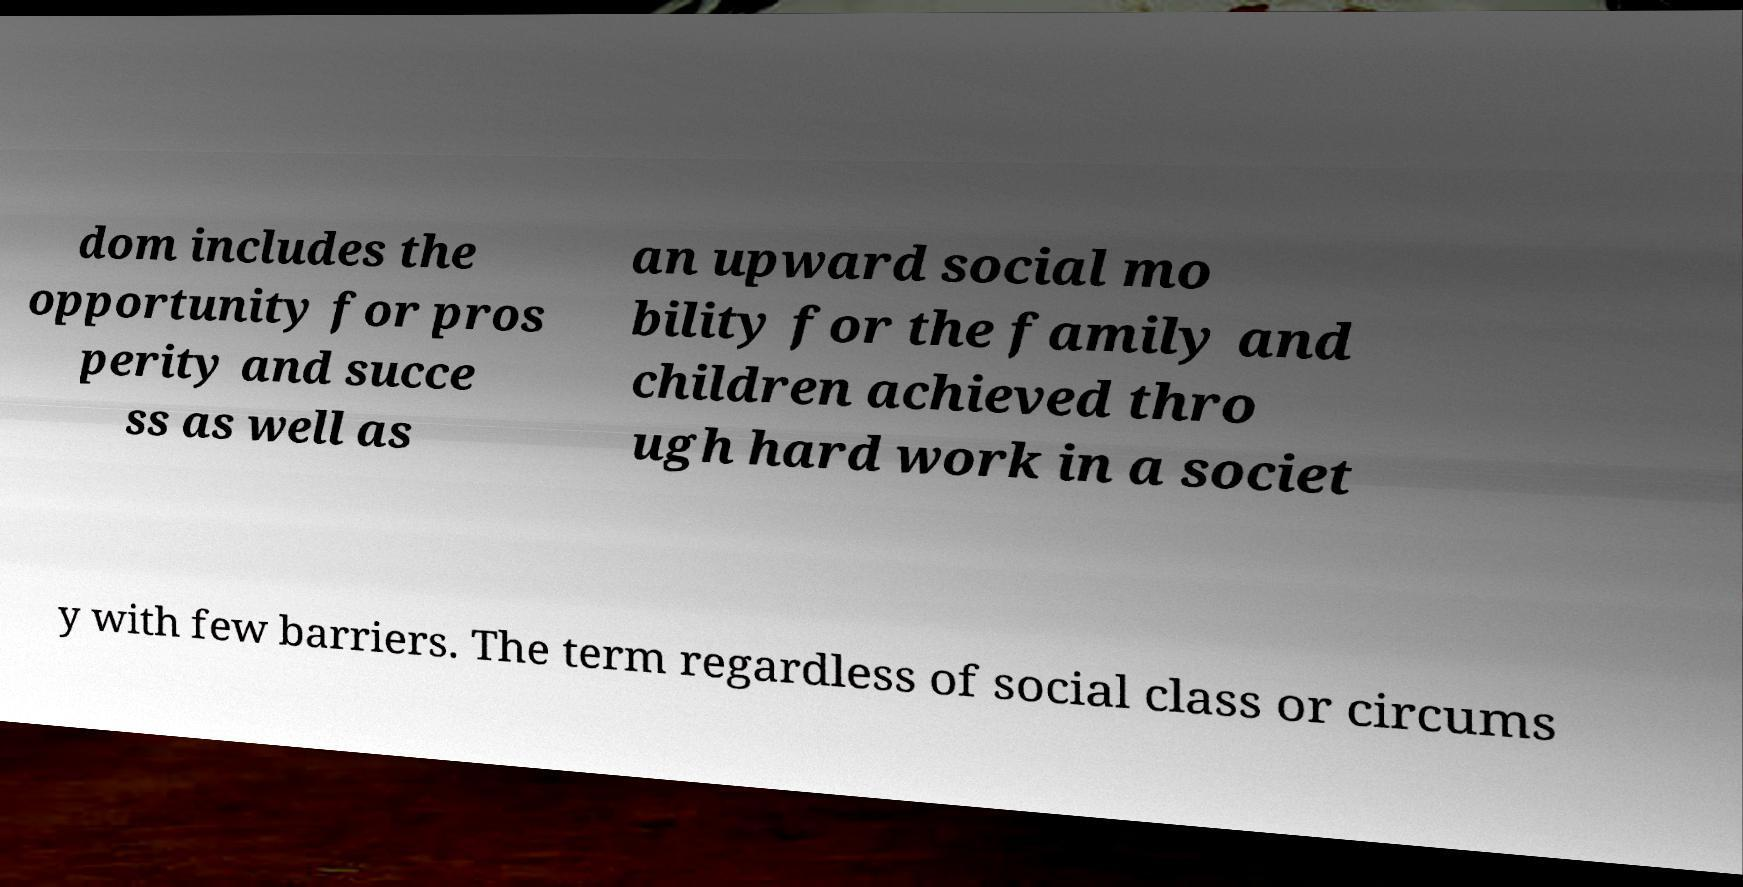There's text embedded in this image that I need extracted. Can you transcribe it verbatim? dom includes the opportunity for pros perity and succe ss as well as an upward social mo bility for the family and children achieved thro ugh hard work in a societ y with few barriers. The term regardless of social class or circums 